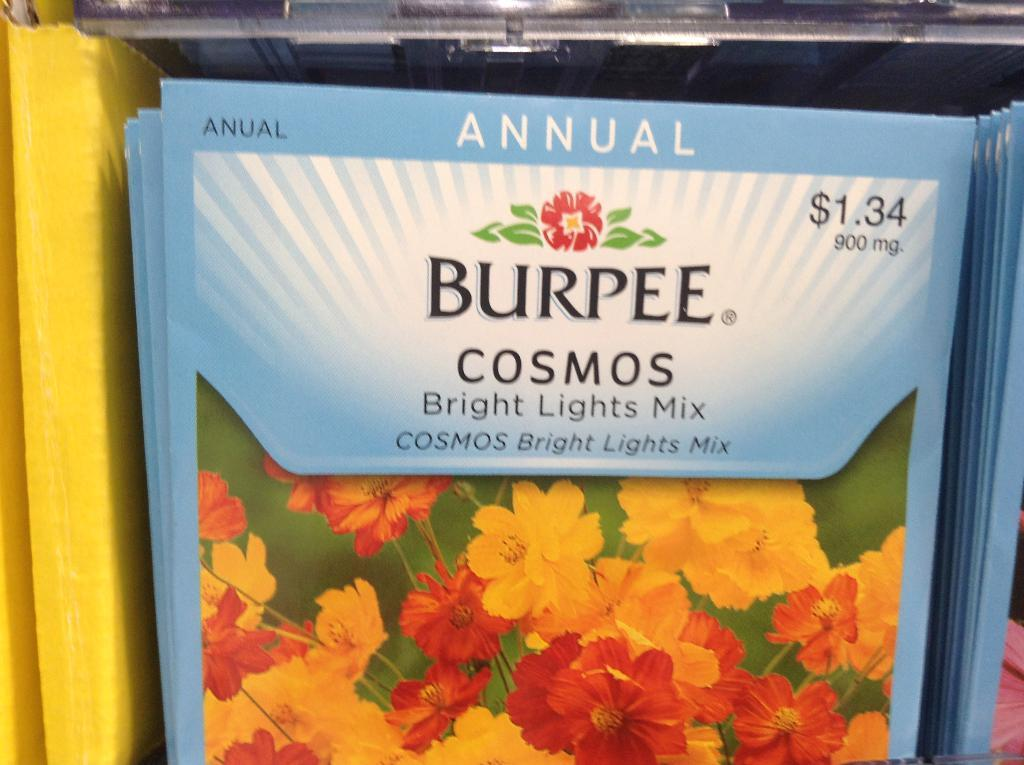What is located in the foreground of the image? There is a pamphlet in the foreground of the image. What can be seen on the pamphlet? There is writing on the pamphlet. What type of orange can be seen hanging from the pamphlet in the image? There is no orange present in the image, and therefore no such object can be observed. 